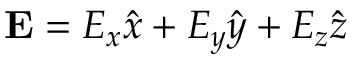Convert formula to latex. <formula><loc_0><loc_0><loc_500><loc_500>E = E _ { x } \hat { x } + E _ { y } \hat { y } + E _ { z } \hat { z }</formula> 